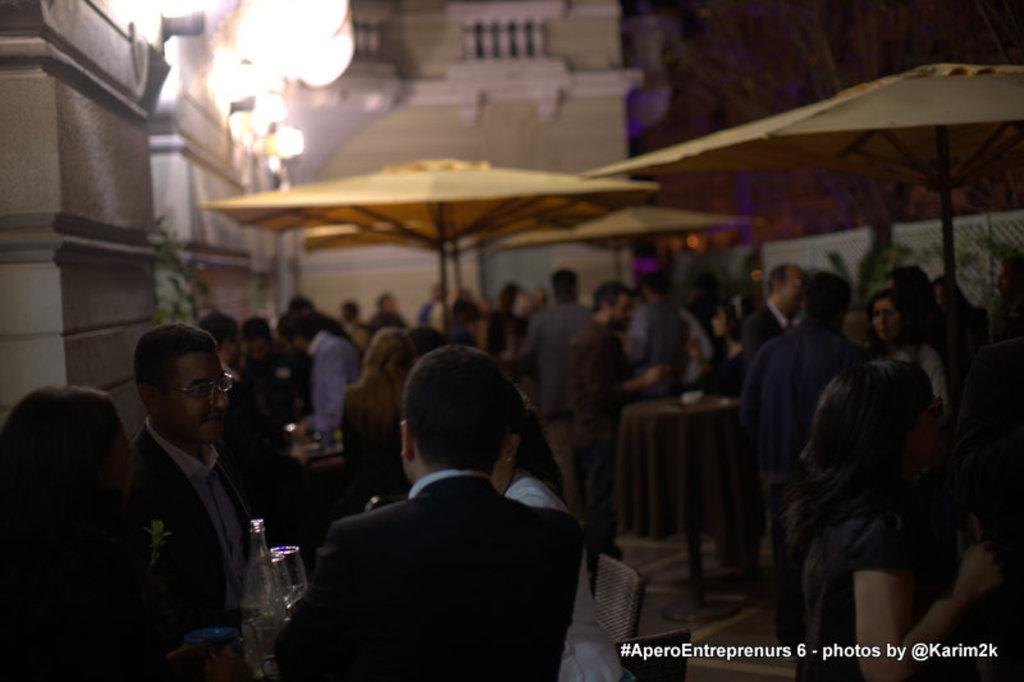Where was the image taken? The image is taken outside. What structures can be seen in the image? There are tents in the image. Who is under the tents? People are under the tents. What can be seen in the background of the image? There is a building in the background of the image. What are the people holding in their hands? People are holding bottles and glasses in their hands. What type of leather is being used to make the team's uniforms in the image? There is no team or uniforms present in the image, so it is not possible to determine the type of leather being used. 